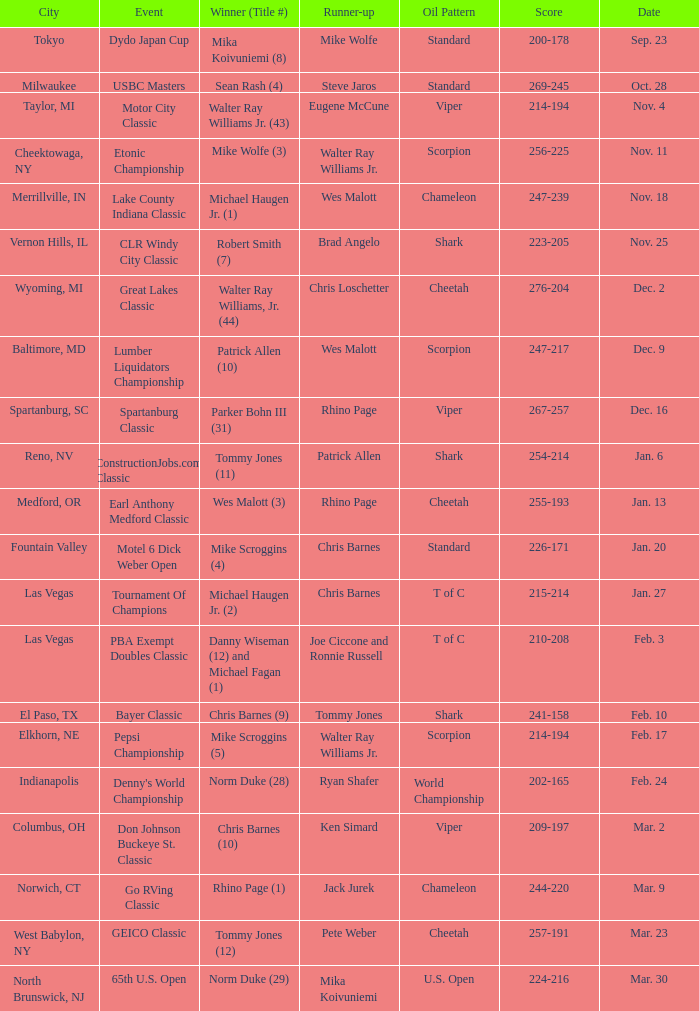Which Oil Pattern has a Winner (Title #) of mike wolfe (3)? Scorpion. I'm looking to parse the entire table for insights. Could you assist me with that? {'header': ['City', 'Event', 'Winner (Title #)', 'Runner-up', 'Oil Pattern', 'Score', 'Date'], 'rows': [['Tokyo', 'Dydo Japan Cup', 'Mika Koivuniemi (8)', 'Mike Wolfe', 'Standard', '200-178', 'Sep. 23'], ['Milwaukee', 'USBC Masters', 'Sean Rash (4)', 'Steve Jaros', 'Standard', '269-245', 'Oct. 28'], ['Taylor, MI', 'Motor City Classic', 'Walter Ray Williams Jr. (43)', 'Eugene McCune', 'Viper', '214-194', 'Nov. 4'], ['Cheektowaga, NY', 'Etonic Championship', 'Mike Wolfe (3)', 'Walter Ray Williams Jr.', 'Scorpion', '256-225', 'Nov. 11'], ['Merrillville, IN', 'Lake County Indiana Classic', 'Michael Haugen Jr. (1)', 'Wes Malott', 'Chameleon', '247-239', 'Nov. 18'], ['Vernon Hills, IL', 'CLR Windy City Classic', 'Robert Smith (7)', 'Brad Angelo', 'Shark', '223-205', 'Nov. 25'], ['Wyoming, MI', 'Great Lakes Classic', 'Walter Ray Williams, Jr. (44)', 'Chris Loschetter', 'Cheetah', '276-204', 'Dec. 2'], ['Baltimore, MD', 'Lumber Liquidators Championship', 'Patrick Allen (10)', 'Wes Malott', 'Scorpion', '247-217', 'Dec. 9'], ['Spartanburg, SC', 'Spartanburg Classic', 'Parker Bohn III (31)', 'Rhino Page', 'Viper', '267-257', 'Dec. 16'], ['Reno, NV', 'ConstructionJobs.com Classic', 'Tommy Jones (11)', 'Patrick Allen', 'Shark', '254-214', 'Jan. 6'], ['Medford, OR', 'Earl Anthony Medford Classic', 'Wes Malott (3)', 'Rhino Page', 'Cheetah', '255-193', 'Jan. 13'], ['Fountain Valley', 'Motel 6 Dick Weber Open', 'Mike Scroggins (4)', 'Chris Barnes', 'Standard', '226-171', 'Jan. 20'], ['Las Vegas', 'Tournament Of Champions', 'Michael Haugen Jr. (2)', 'Chris Barnes', 'T of C', '215-214', 'Jan. 27'], ['Las Vegas', 'PBA Exempt Doubles Classic', 'Danny Wiseman (12) and Michael Fagan (1)', 'Joe Ciccone and Ronnie Russell', 'T of C', '210-208', 'Feb. 3'], ['El Paso, TX', 'Bayer Classic', 'Chris Barnes (9)', 'Tommy Jones', 'Shark', '241-158', 'Feb. 10'], ['Elkhorn, NE', 'Pepsi Championship', 'Mike Scroggins (5)', 'Walter Ray Williams Jr.', 'Scorpion', '214-194', 'Feb. 17'], ['Indianapolis', "Denny's World Championship", 'Norm Duke (28)', 'Ryan Shafer', 'World Championship', '202-165', 'Feb. 24'], ['Columbus, OH', 'Don Johnson Buckeye St. Classic', 'Chris Barnes (10)', 'Ken Simard', 'Viper', '209-197', 'Mar. 2'], ['Norwich, CT', 'Go RVing Classic', 'Rhino Page (1)', 'Jack Jurek', 'Chameleon', '244-220', 'Mar. 9'], ['West Babylon, NY', 'GEICO Classic', 'Tommy Jones (12)', 'Pete Weber', 'Cheetah', '257-191', 'Mar. 23'], ['North Brunswick, NJ', '65th U.S. Open', 'Norm Duke (29)', 'Mika Koivuniemi', 'U.S. Open', '224-216', 'Mar. 30']]} 